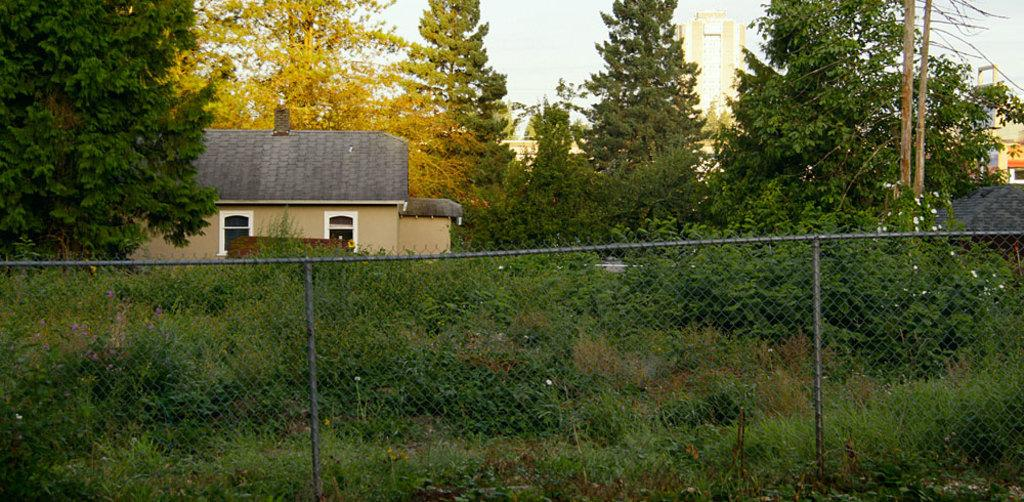What is located in the foreground of the image? There are plants and fencing in the foreground of the image. What can be seen in the middle of the image? There are trees and houses in the middle of the image. What is visible in the background of the image? There are buildings and the sky in the background of the image. What type of glove is being advertised in the image? There is no glove or advertisement present in the image. What liquid is visible in the image? There is no liquid visible in the image. 